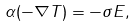Convert formula to latex. <formula><loc_0><loc_0><loc_500><loc_500>\alpha ( - \nabla T ) = - \sigma { E } ,</formula> 